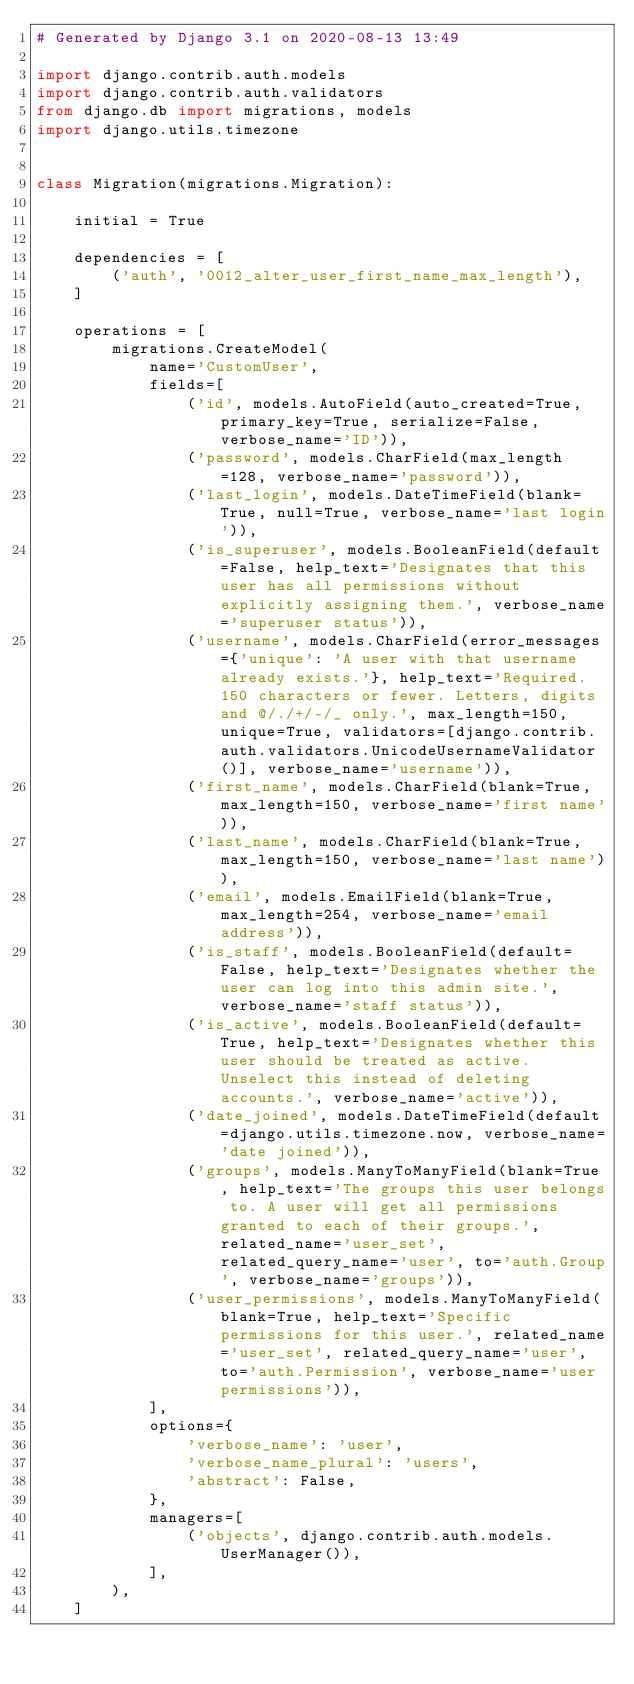Convert code to text. <code><loc_0><loc_0><loc_500><loc_500><_Python_># Generated by Django 3.1 on 2020-08-13 13:49

import django.contrib.auth.models
import django.contrib.auth.validators
from django.db import migrations, models
import django.utils.timezone


class Migration(migrations.Migration):

    initial = True

    dependencies = [
        ('auth', '0012_alter_user_first_name_max_length'),
    ]

    operations = [
        migrations.CreateModel(
            name='CustomUser',
            fields=[
                ('id', models.AutoField(auto_created=True, primary_key=True, serialize=False, verbose_name='ID')),
                ('password', models.CharField(max_length=128, verbose_name='password')),
                ('last_login', models.DateTimeField(blank=True, null=True, verbose_name='last login')),
                ('is_superuser', models.BooleanField(default=False, help_text='Designates that this user has all permissions without explicitly assigning them.', verbose_name='superuser status')),
                ('username', models.CharField(error_messages={'unique': 'A user with that username already exists.'}, help_text='Required. 150 characters or fewer. Letters, digits and @/./+/-/_ only.', max_length=150, unique=True, validators=[django.contrib.auth.validators.UnicodeUsernameValidator()], verbose_name='username')),
                ('first_name', models.CharField(blank=True, max_length=150, verbose_name='first name')),
                ('last_name', models.CharField(blank=True, max_length=150, verbose_name='last name')),
                ('email', models.EmailField(blank=True, max_length=254, verbose_name='email address')),
                ('is_staff', models.BooleanField(default=False, help_text='Designates whether the user can log into this admin site.', verbose_name='staff status')),
                ('is_active', models.BooleanField(default=True, help_text='Designates whether this user should be treated as active. Unselect this instead of deleting accounts.', verbose_name='active')),
                ('date_joined', models.DateTimeField(default=django.utils.timezone.now, verbose_name='date joined')),
                ('groups', models.ManyToManyField(blank=True, help_text='The groups this user belongs to. A user will get all permissions granted to each of their groups.', related_name='user_set', related_query_name='user', to='auth.Group', verbose_name='groups')),
                ('user_permissions', models.ManyToManyField(blank=True, help_text='Specific permissions for this user.', related_name='user_set', related_query_name='user', to='auth.Permission', verbose_name='user permissions')),
            ],
            options={
                'verbose_name': 'user',
                'verbose_name_plural': 'users',
                'abstract': False,
            },
            managers=[
                ('objects', django.contrib.auth.models.UserManager()),
            ],
        ),
    ]
</code> 